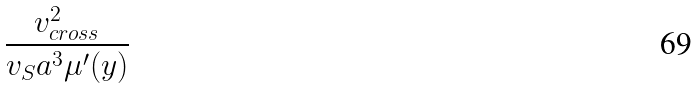<formula> <loc_0><loc_0><loc_500><loc_500>\frac { v _ { c r o s s } ^ { 2 } } { v _ { S } a ^ { 3 } \mu ^ { \prime } ( y ) }</formula> 